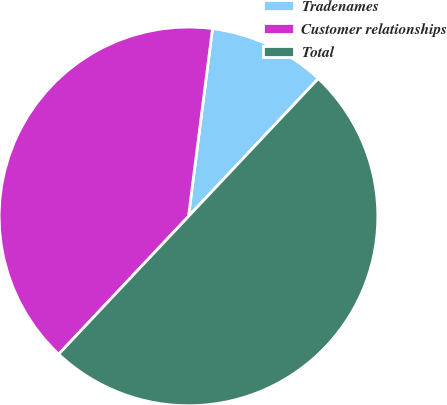<chart> <loc_0><loc_0><loc_500><loc_500><pie_chart><fcel>Tradenames<fcel>Customer relationships<fcel>Total<nl><fcel>10.0%<fcel>40.0%<fcel>50.0%<nl></chart> 